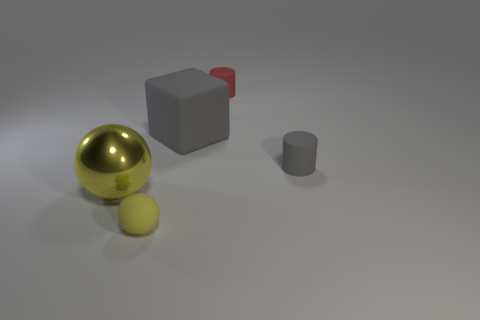Add 2 gray cylinders. How many objects exist? 7 Subtract all spheres. How many objects are left? 3 Add 4 large yellow spheres. How many large yellow spheres exist? 5 Subtract 0 purple cylinders. How many objects are left? 5 Subtract all small balls. Subtract all big yellow spheres. How many objects are left? 3 Add 2 small yellow balls. How many small yellow balls are left? 3 